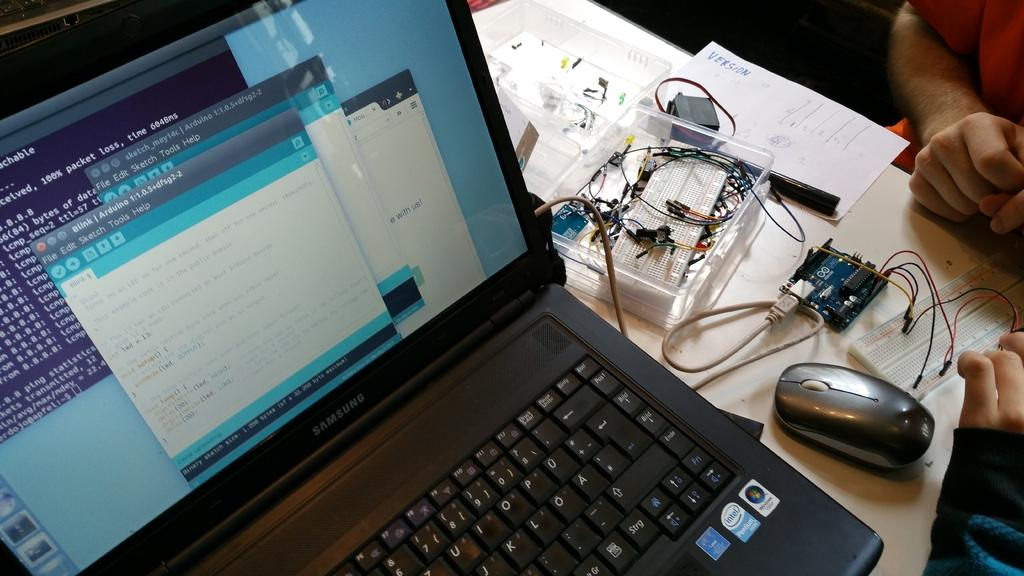<image>
Provide a brief description of the given image. A laptop computer that has that packet loss on the command line on its screen. 